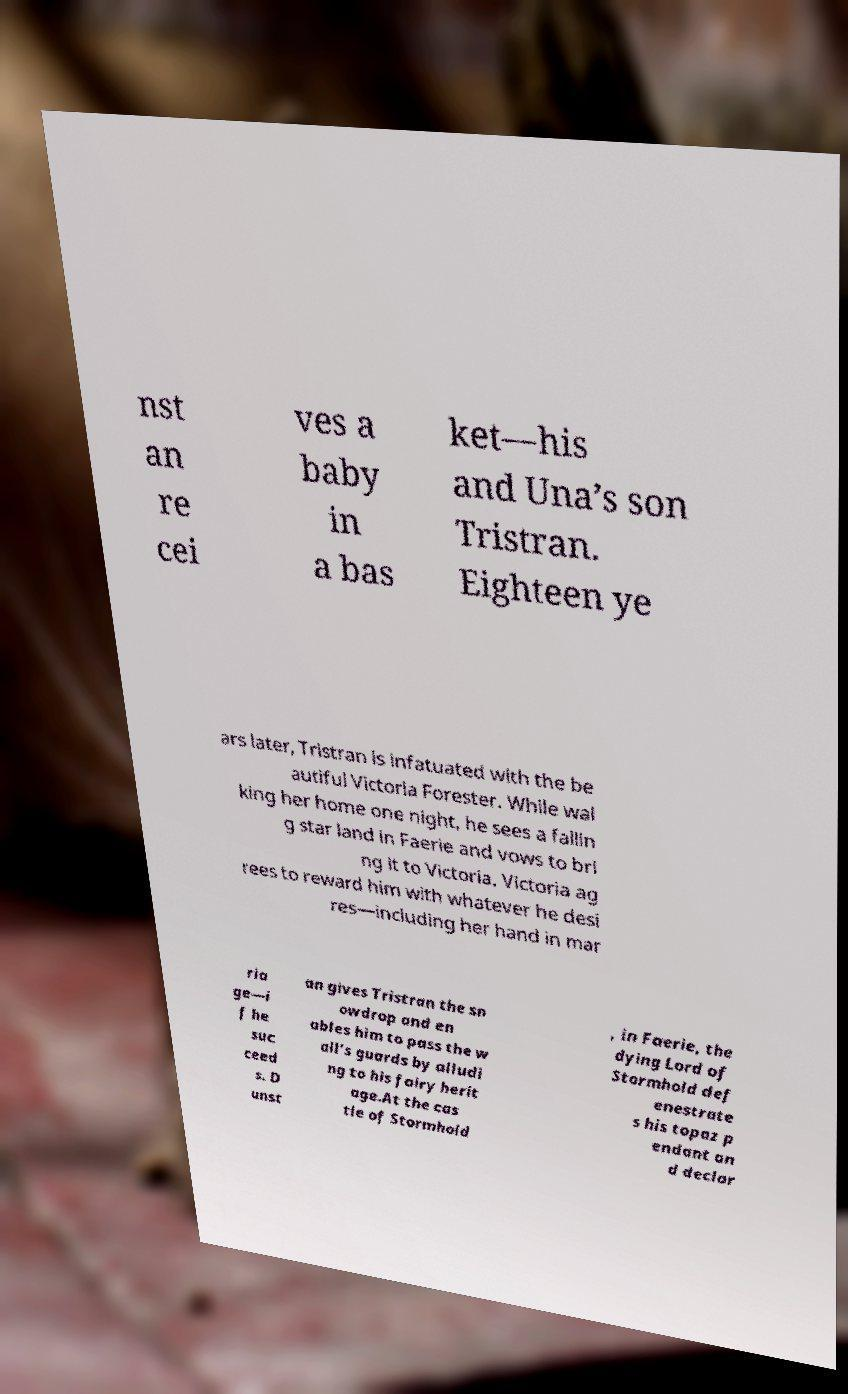Could you extract and type out the text from this image? nst an re cei ves a baby in a bas ket—his and Una’s son Tristran. Eighteen ye ars later, Tristran is infatuated with the be autiful Victoria Forester. While wal king her home one night, he sees a fallin g star land in Faerie and vows to bri ng it to Victoria. Victoria ag rees to reward him with whatever he desi res—including her hand in mar ria ge—i f he suc ceed s. D unst an gives Tristran the sn owdrop and en ables him to pass the w all’s guards by alludi ng to his fairy herit age.At the cas tle of Stormhold , in Faerie, the dying Lord of Stormhold def enestrate s his topaz p endant an d declar 